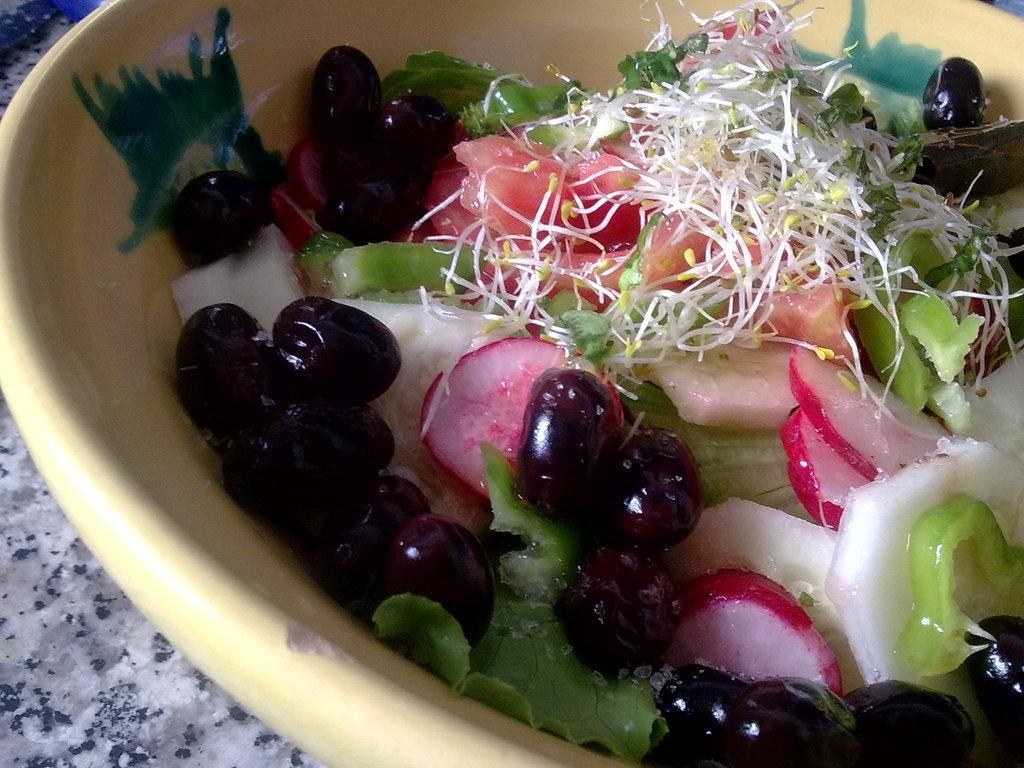Describe this image in one or two sentences. In this image in the foreground there is one bowl, and in the bowl there is some salad and at the bottom there is a table. 